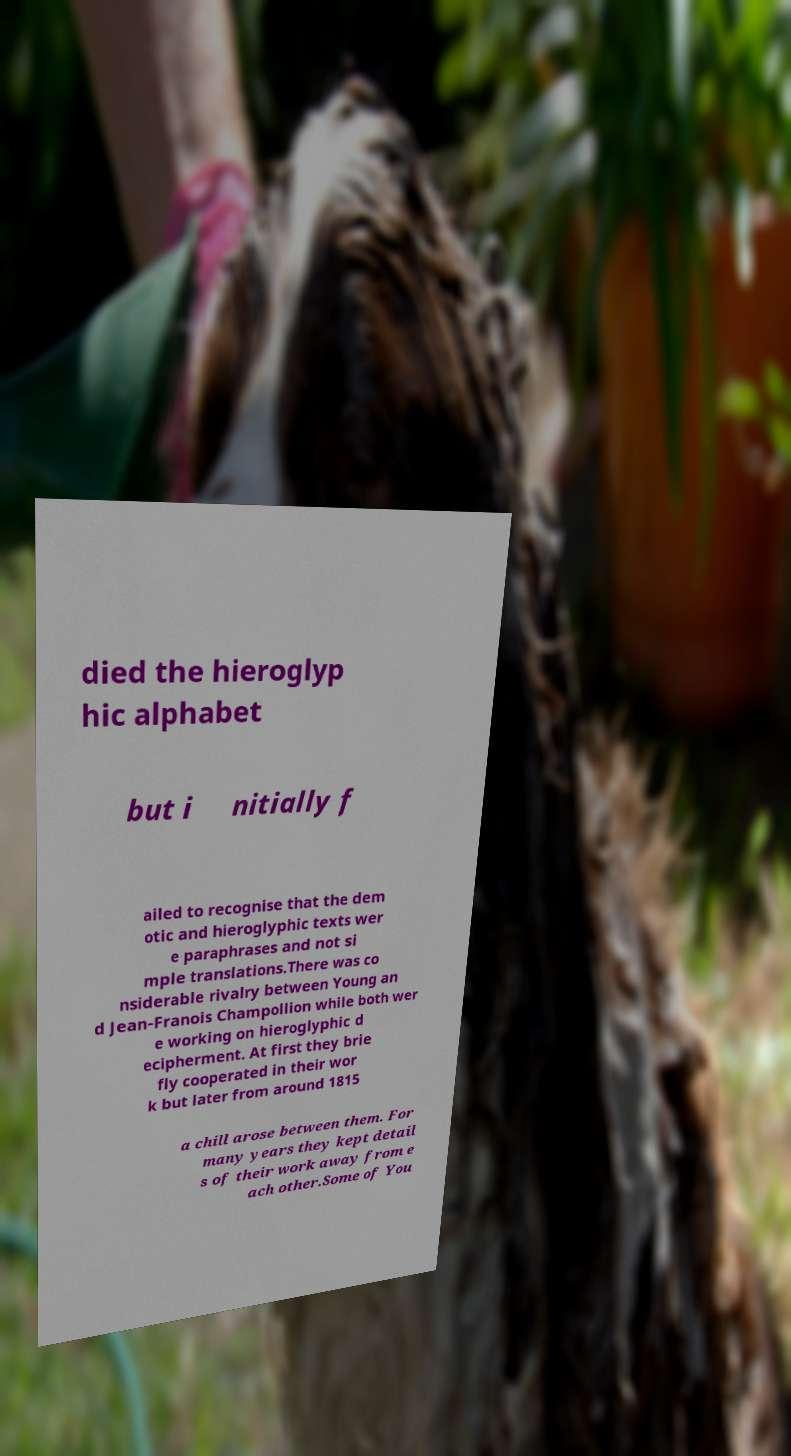There's text embedded in this image that I need extracted. Can you transcribe it verbatim? died the hieroglyp hic alphabet but i nitially f ailed to recognise that the dem otic and hieroglyphic texts wer e paraphrases and not si mple translations.There was co nsiderable rivalry between Young an d Jean-Franois Champollion while both wer e working on hieroglyphic d ecipherment. At first they brie fly cooperated in their wor k but later from around 1815 a chill arose between them. For many years they kept detail s of their work away from e ach other.Some of You 